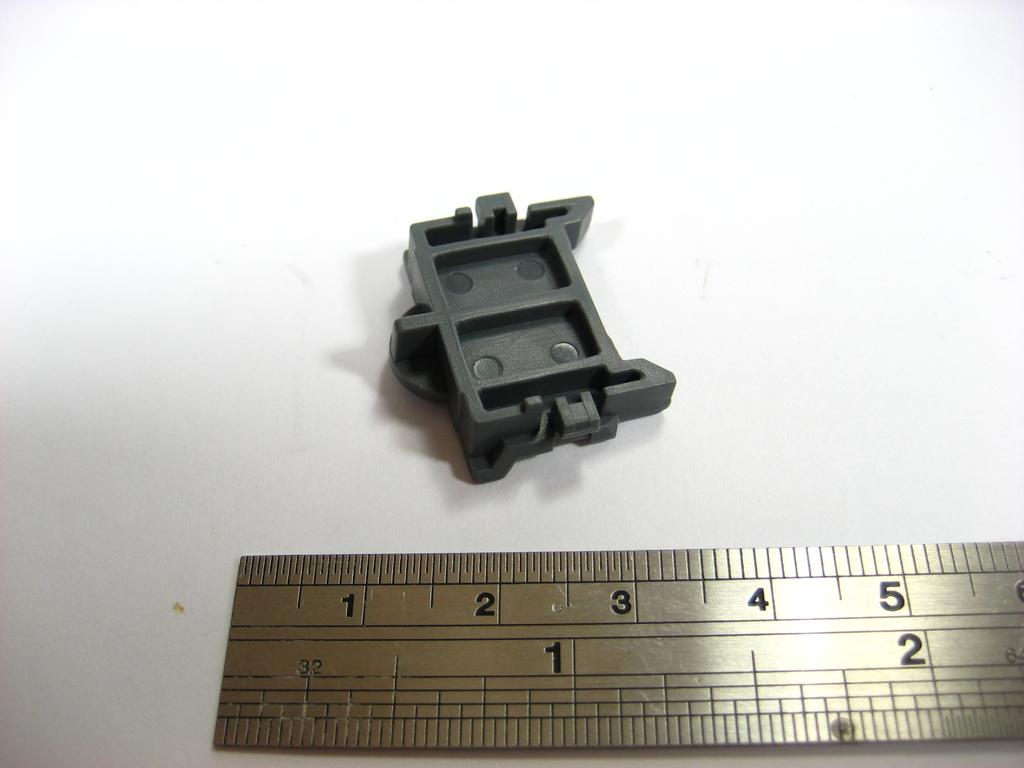Provide a one-sentence caption for the provided image. A ruler showing numbers 1 to 5 and a grey plastic part laying on a white table. 